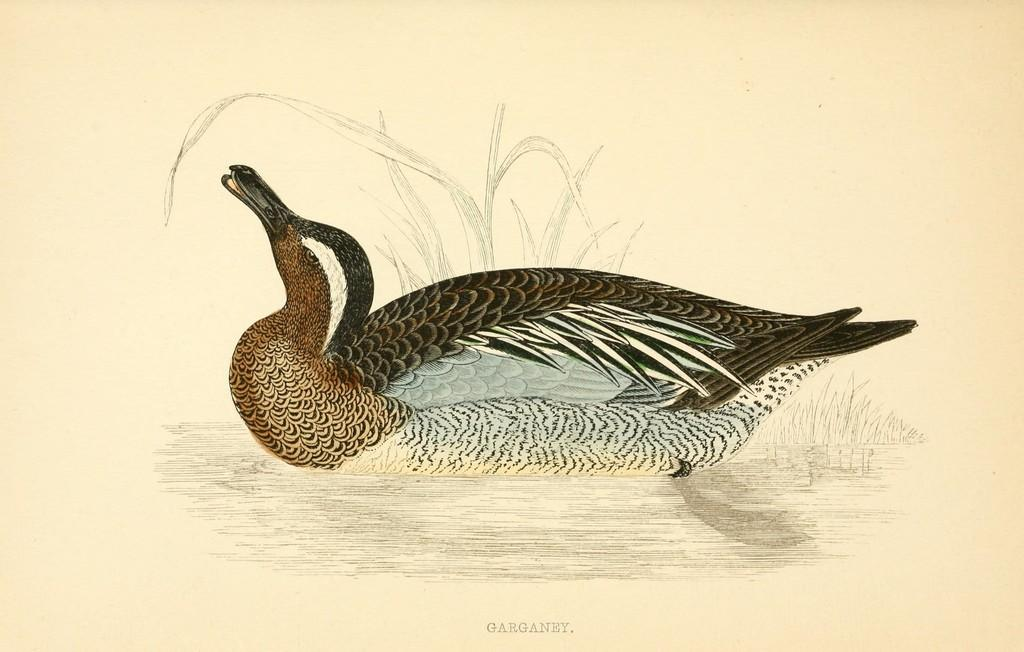What type of animal is depicted in the drawing in the image? There is a drawing of a bird in the image. What other element is present in the drawing in the image? There is a drawing of grass in the image. Where is the nest of the bird in the image? There is no nest present in the image; it only features a drawing of a bird and grass. What type of neck is visible on the man in the image? There is no man present in the image; it only features a drawing of a bird and grass. 